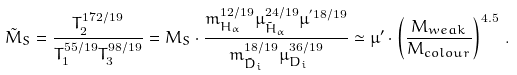Convert formula to latex. <formula><loc_0><loc_0><loc_500><loc_500>\tilde { M } _ { S } = \frac { T _ { 2 } ^ { 1 7 2 / 1 9 } } { T _ { 1 } ^ { 5 5 / 1 9 } T _ { 3 } ^ { 9 8 / 1 9 } } = M _ { S } \cdot \frac { m _ { H _ { \alpha } } ^ { 1 2 / 1 9 } \mu _ { \tilde { H } _ { \alpha } } ^ { 2 4 / 1 9 } \mu ^ { ^ { \prime } 1 8 / 1 9 } } { m _ { \tilde { D } _ { i } } ^ { 1 8 / 1 9 } \mu _ { D _ { i } } ^ { 3 6 / 1 9 } } \simeq \mu ^ { \prime } \cdot \left ( \frac { M _ { w e a k } } { M _ { c o l o u r } } \right ) ^ { 4 . 5 } \, .</formula> 